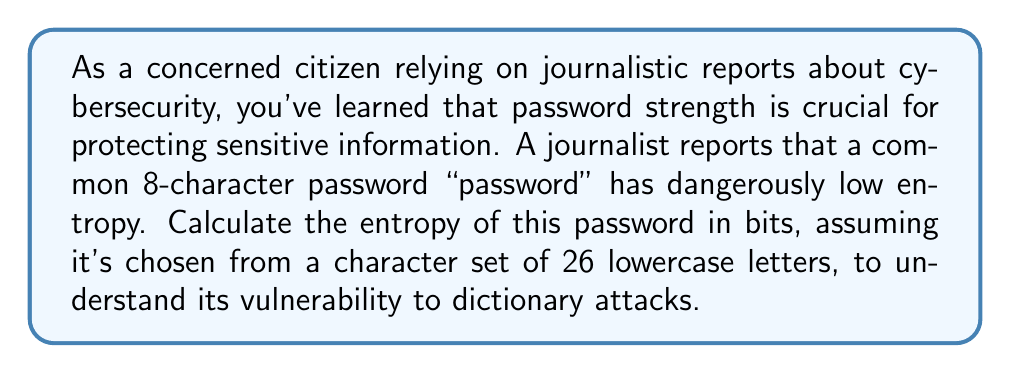Help me with this question. To calculate the entropy of a password, we use the formula:

$$ H = L \log_2(N) $$

Where:
$H$ = entropy in bits
$L$ = length of the password
$N$ = size of the character set

For this password:
$L = 8$ (8 characters long)
$N = 26$ (26 lowercase letters)

Let's substitute these values into the formula:

$$ H = 8 \log_2(26) $$

Now, let's calculate:

1) First, calculate $\log_2(26)$:
   $\log_2(26) \approx 4.7004$ (rounded to 4 decimal places)

2) Multiply by the length:
   $H = 8 * 4.7004 = 37.6032$ bits

Therefore, the entropy of the password "password" is approximately 37.6032 bits.

This relatively low entropy indicates that the password is weak and vulnerable to dictionary attacks. For comparison, a strong password typically has at least 80 bits of entropy.
Answer: 37.6032 bits 